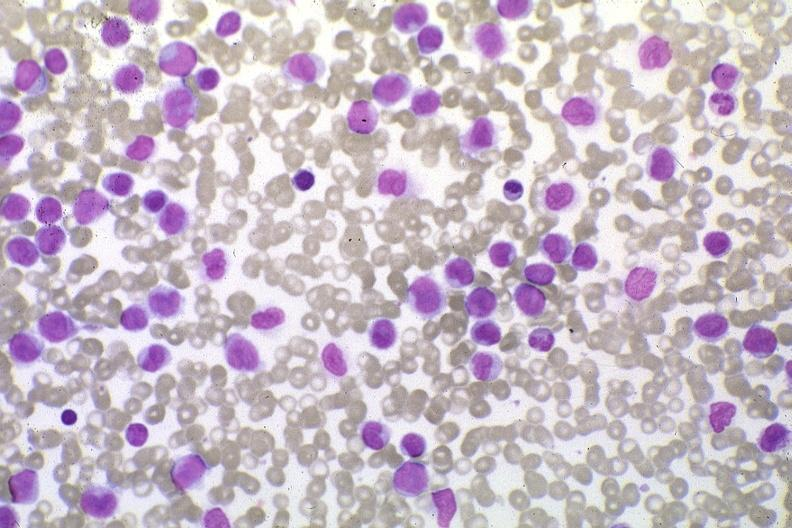do external view of spleen with multiple recent infarcts stain pleomorphic leukemic cells in peripheral blood prior to therapy?
Answer the question using a single word or phrase. No 